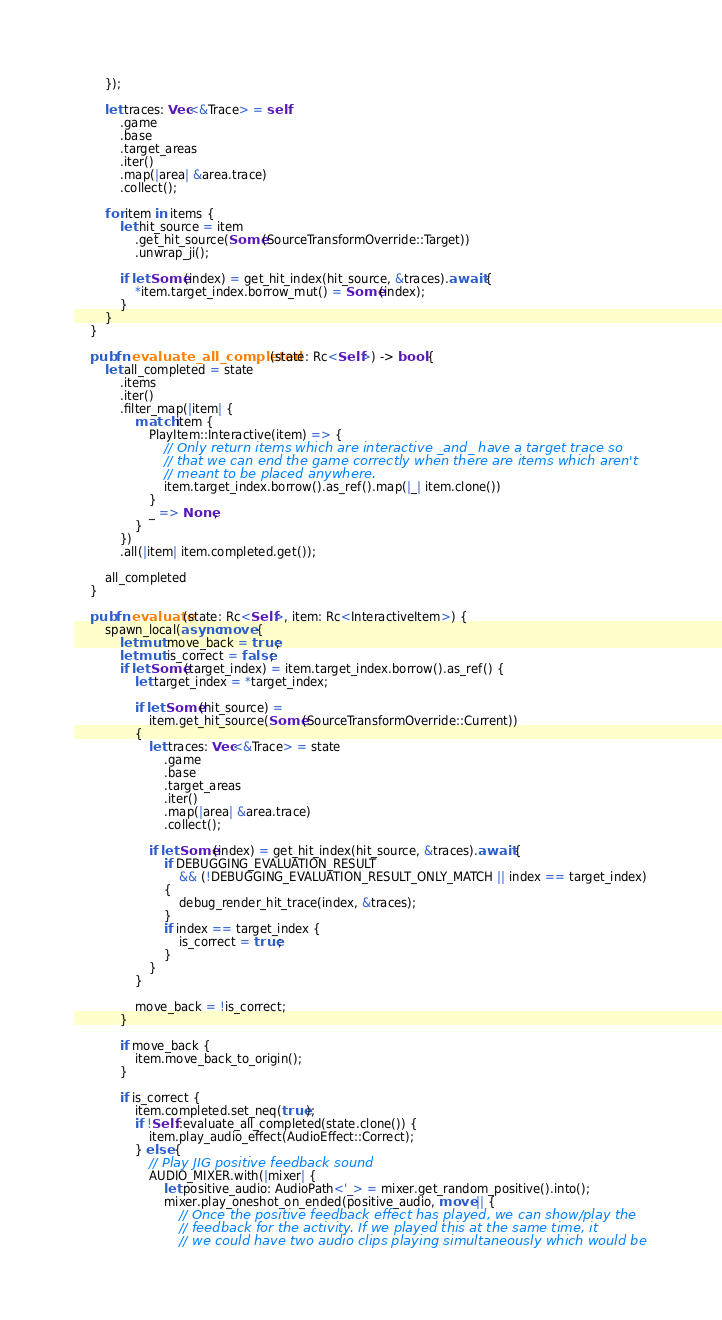<code> <loc_0><loc_0><loc_500><loc_500><_Rust_>        });

        let traces: Vec<&Trace> = self
            .game
            .base
            .target_areas
            .iter()
            .map(|area| &area.trace)
            .collect();

        for item in items {
            let hit_source = item
                .get_hit_source(Some(SourceTransformOverride::Target))
                .unwrap_ji();

            if let Some(index) = get_hit_index(hit_source, &traces).await {
                *item.target_index.borrow_mut() = Some(index);
            }
        }
    }

    pub fn evaluate_all_completed(state: Rc<Self>) -> bool {
        let all_completed = state
            .items
            .iter()
            .filter_map(|item| {
                match item {
                    PlayItem::Interactive(item) => {
                        // Only return items which are interactive _and_ have a target trace so
                        // that we can end the game correctly when there are items which aren't
                        // meant to be placed anywhere.
                        item.target_index.borrow().as_ref().map(|_| item.clone())
                    }
                    _ => None,
                }
            })
            .all(|item| item.completed.get());

        all_completed
    }

    pub fn evaluate(state: Rc<Self>, item: Rc<InteractiveItem>) {
        spawn_local(async move {
            let mut move_back = true;
            let mut is_correct = false;
            if let Some(target_index) = item.target_index.borrow().as_ref() {
                let target_index = *target_index;

                if let Some(hit_source) =
                    item.get_hit_source(Some(SourceTransformOverride::Current))
                {
                    let traces: Vec<&Trace> = state
                        .game
                        .base
                        .target_areas
                        .iter()
                        .map(|area| &area.trace)
                        .collect();

                    if let Some(index) = get_hit_index(hit_source, &traces).await {
                        if DEBUGGING_EVALUATION_RESULT
                            && (!DEBUGGING_EVALUATION_RESULT_ONLY_MATCH || index == target_index)
                        {
                            debug_render_hit_trace(index, &traces);
                        }
                        if index == target_index {
                            is_correct = true;
                        }
                    }
                }

                move_back = !is_correct;
            }

            if move_back {
                item.move_back_to_origin();
            }

            if is_correct {
                item.completed.set_neq(true);
                if !Self::evaluate_all_completed(state.clone()) {
                    item.play_audio_effect(AudioEffect::Correct);
                } else {
                    // Play JIG positive feedback sound
                    AUDIO_MIXER.with(|mixer| {
                        let positive_audio: AudioPath<'_> = mixer.get_random_positive().into();
                        mixer.play_oneshot_on_ended(positive_audio, move || {
                            // Once the positive feedback effect has played, we can show/play the
                            // feedback for the activity. If we played this at the same time, it
                            // we could have two audio clips playing simultaneously which would be</code> 